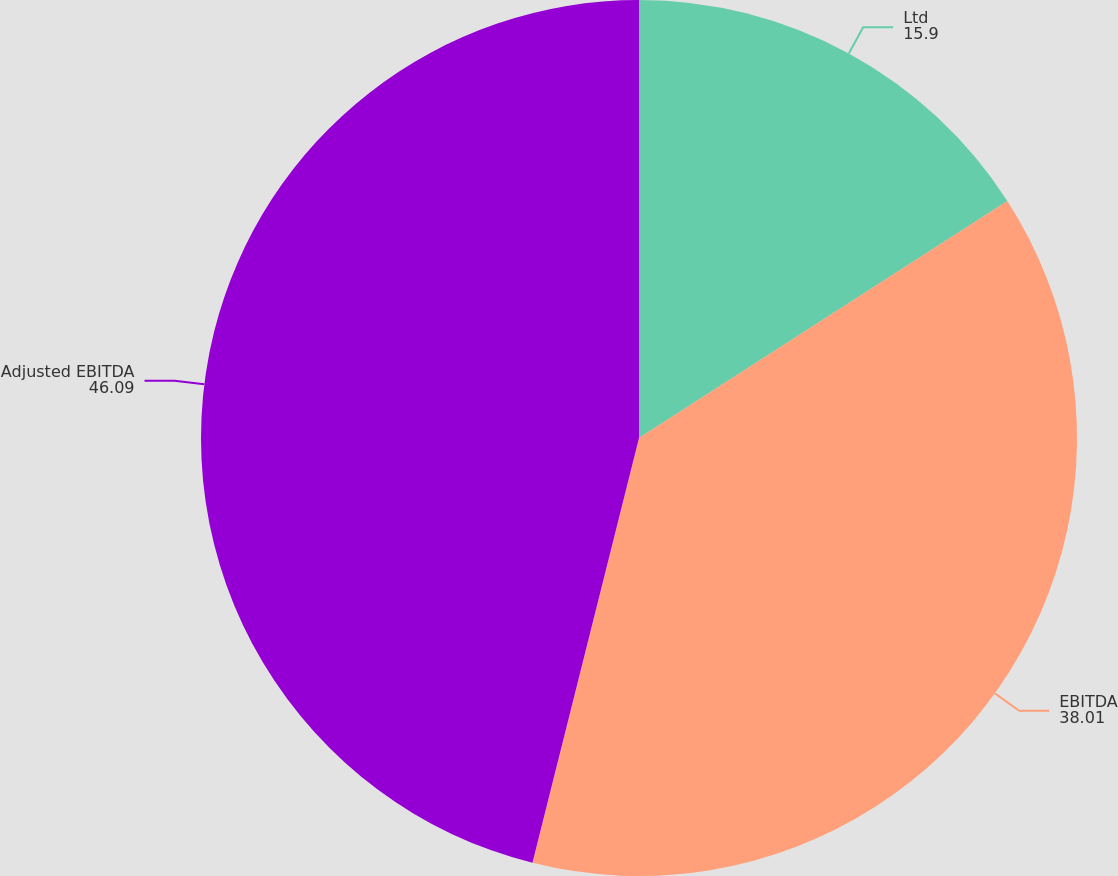Convert chart to OTSL. <chart><loc_0><loc_0><loc_500><loc_500><pie_chart><fcel>Ltd<fcel>EBITDA<fcel>Adjusted EBITDA<nl><fcel>15.9%<fcel>38.01%<fcel>46.09%<nl></chart> 